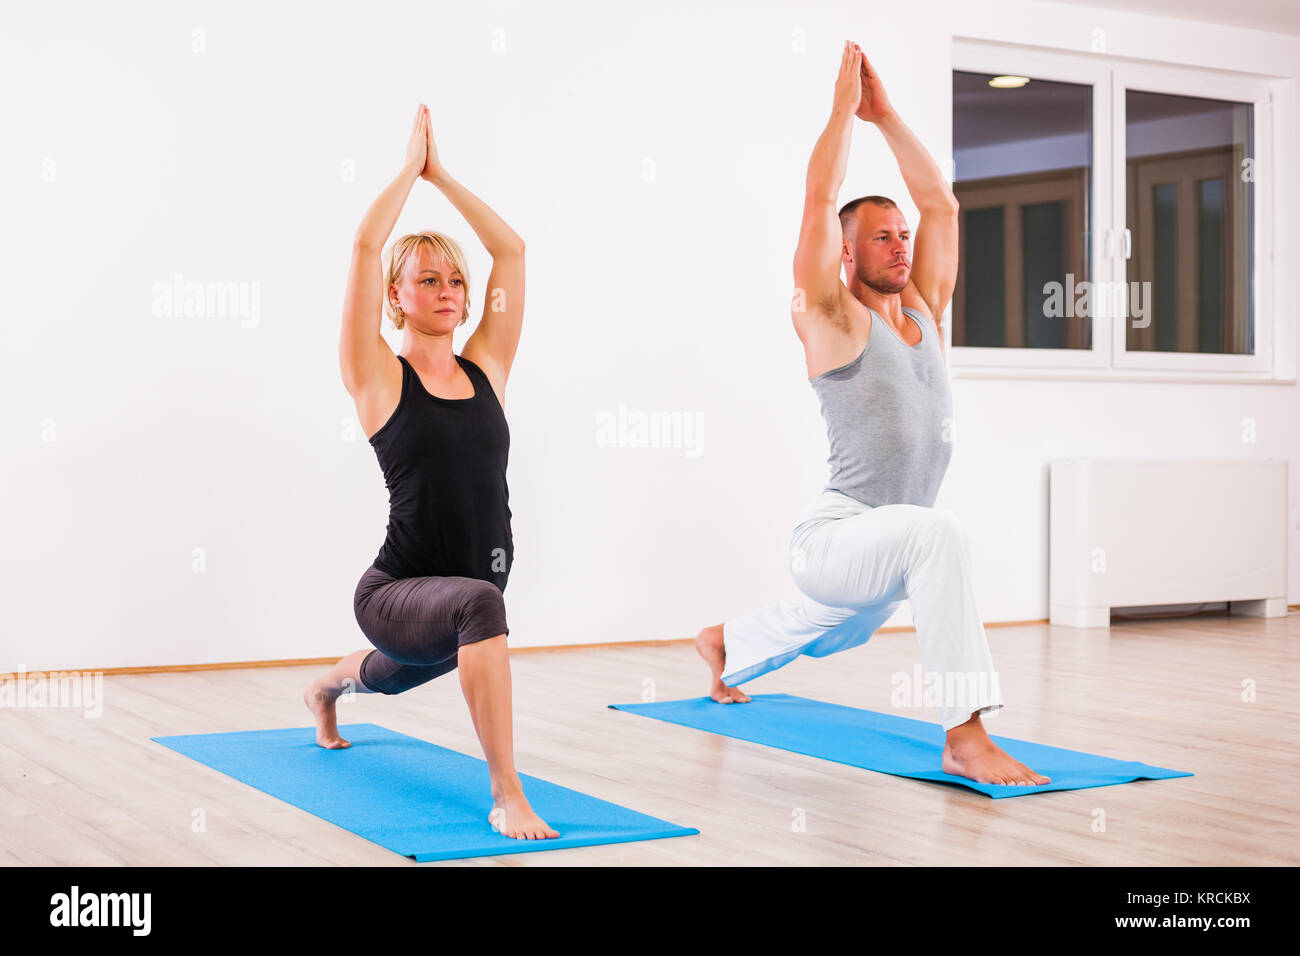What are the benefits of practicing yoga poses like these? Yoga poses such as the Anjaneyasana play a crucial role in enhancing physical flexibility and strength, particularly in the legs and core muscles. Additionally, they boost mental focus and contribute to emotional stability. Regular practice can improve posture, alleviate stress, and boost overall health and well-being. 